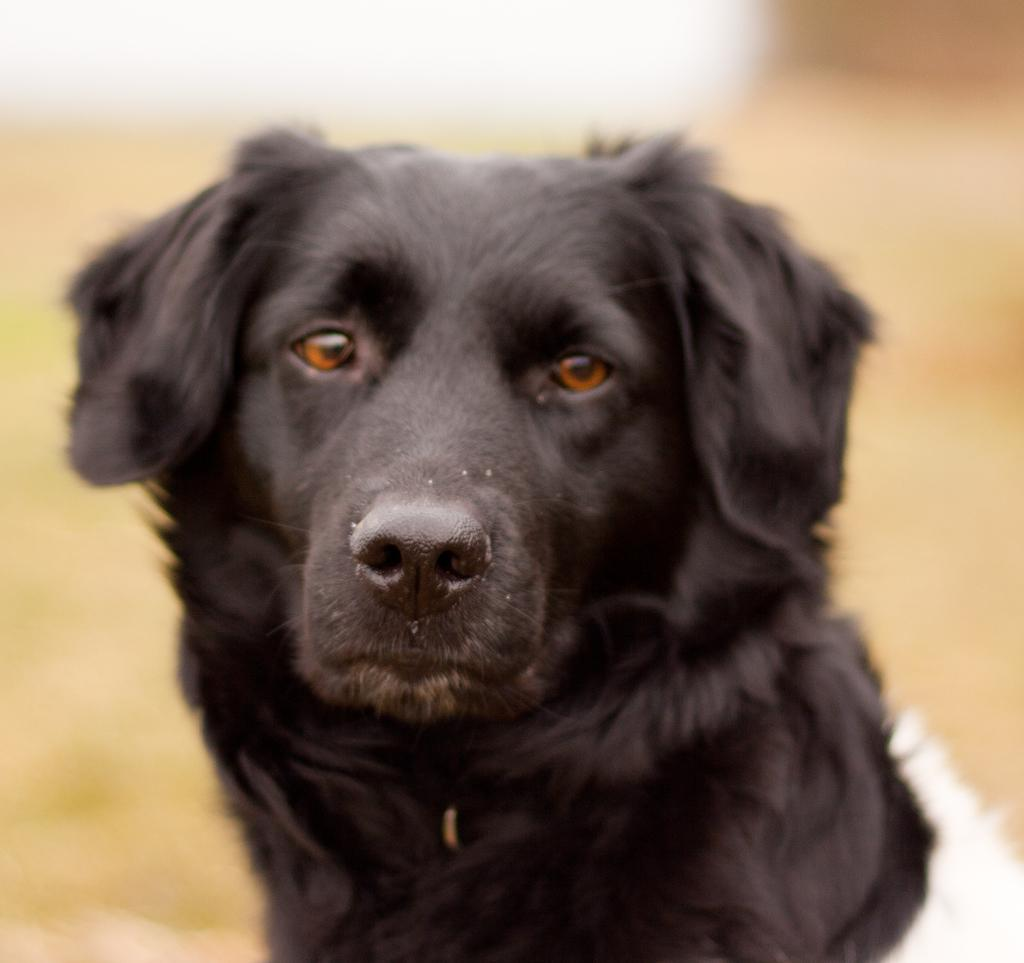What type of animal is present in the image? There is a dog in the image. Can you describe the background of the image? The background of the image is blurred. What type of secretary can be seen working in the image? There is no secretary present in the image; it features a dog and a blurred background. How many eggs are visible in the image? There are no eggs present in the image. 